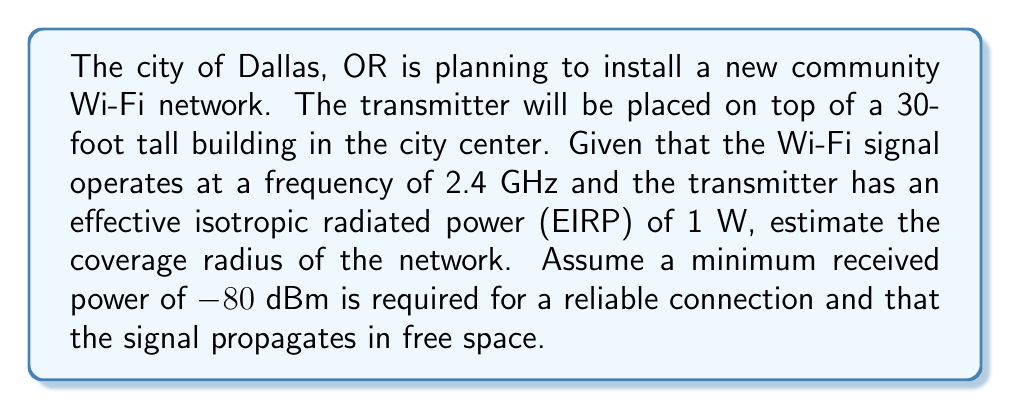Could you help me with this problem? To solve this problem, we'll use the Friis transmission equation from electromagnetic field theory:

$$P_r = P_t + G_t + G_r - 20\log_{10}\left(\frac{4\pi d}{\lambda}\right)$$

Where:
$P_r$ = Received power (dBm)
$P_t$ = Transmitted power (dBm)
$G_t$ = Transmitter antenna gain (dBi)
$G_r$ = Receiver antenna gain (dBi)
$d$ = Distance between transmitter and receiver (m)
$\lambda$ = Wavelength (m)

Step 1: Convert EIRP to dBm
EIRP = 1 W = 1000 mW
$P_t = 10\log_{10}(1000) = 30$ dBm

Step 2: Calculate wavelength
$\lambda = \frac{c}{f} = \frac{3 \times 10^8}{2.4 \times 10^9} = 0.125$ m

Step 3: Rearrange Friis equation to solve for d
$$-80 = 30 + 0 + 0 - 20\log_{10}\left(\frac{4\pi d}{0.125}\right)$$
$$-110 = -20\log_{10}\left(\frac{4\pi d}{0.125}\right)$$
$$5.5 = \log_{10}\left(\frac{4\pi d}{0.125}\right)$$
$$10^{5.5} = \frac{4\pi d}{0.125}$$
$$d = \frac{0.125 \times 10^{5.5}}{4\pi} \approx 1,740.8$ m

Step 4: Add height of the building
Total coverage radius = $\sqrt{1740.8^2 + 30^2} \approx 1,741$ m
Answer: 1,741 m 